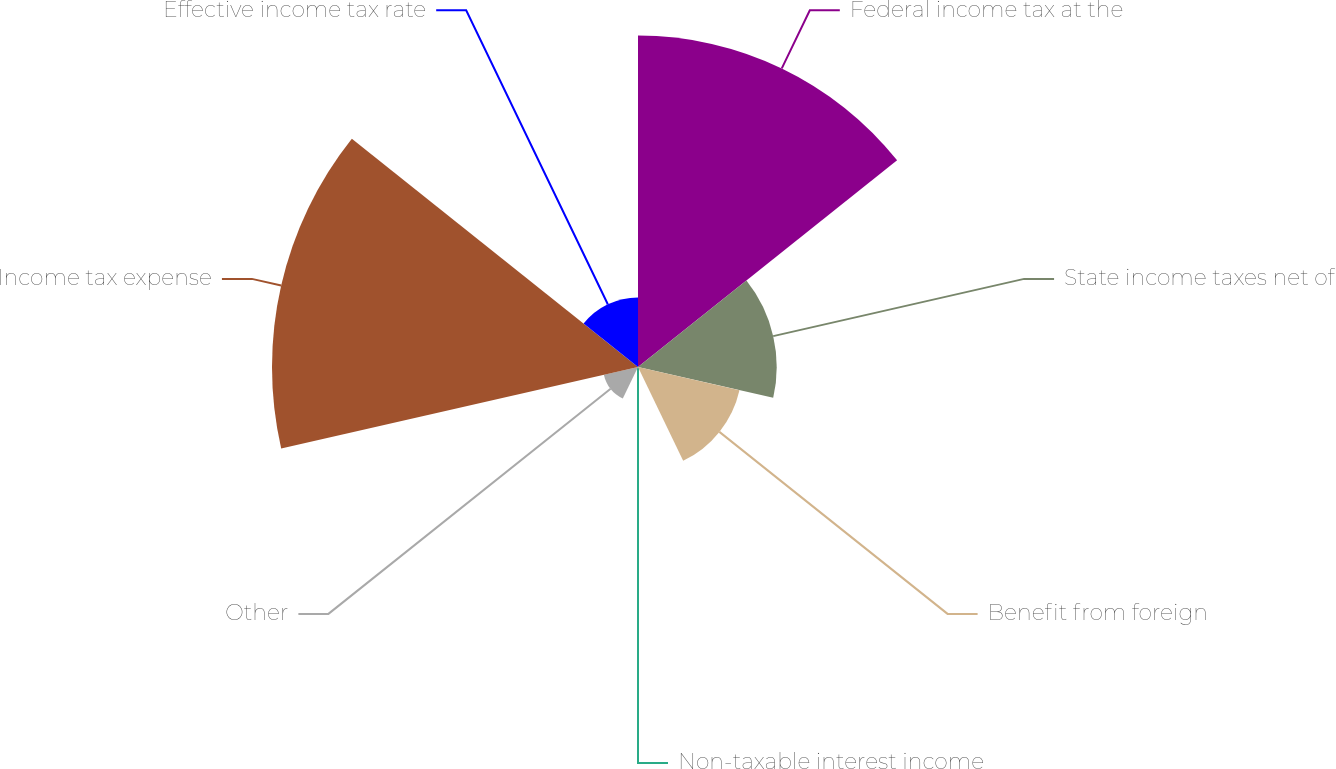Convert chart. <chart><loc_0><loc_0><loc_500><loc_500><pie_chart><fcel>Federal income tax at the<fcel>State income taxes net of<fcel>Benefit from foreign<fcel>Non-taxable interest income<fcel>Other<fcel>Income tax expense<fcel>Effective income tax rate<nl><fcel>31.71%<fcel>13.27%<fcel>9.96%<fcel>0.04%<fcel>3.35%<fcel>35.02%<fcel>6.66%<nl></chart> 